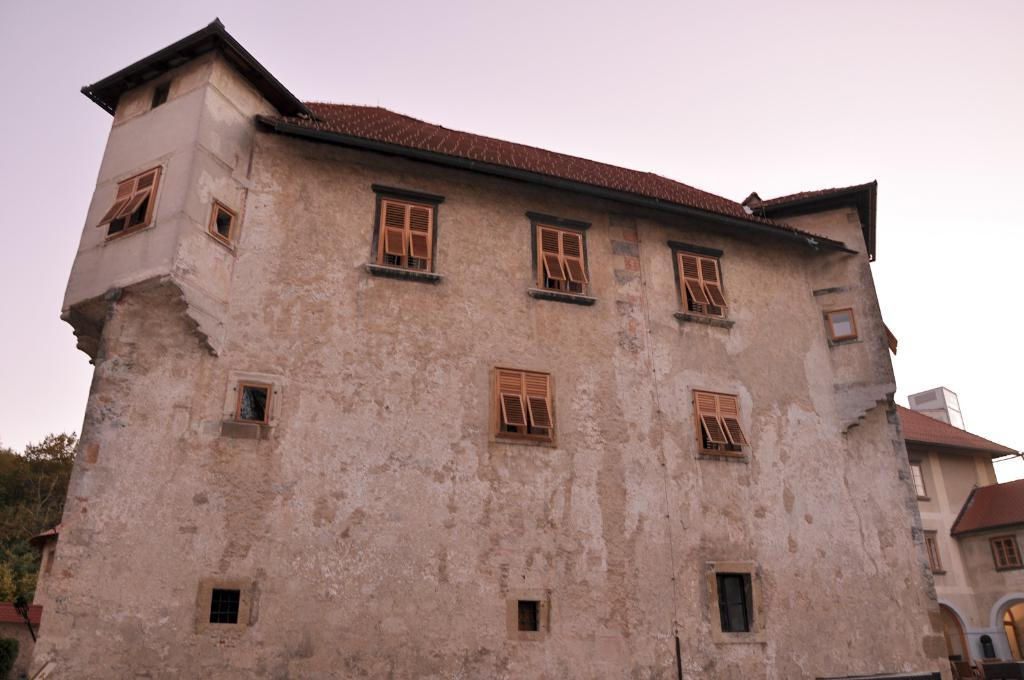What is the main structure in the middle of the image? There is a building in the middle of the image. What type of vegetation is on the left side of the image? There are trees on the left side of the image. What is visible at the top of the image? The sky is visible at the top of the image. What feature can be seen on the building? There are windows in the middle of the building. Where is the scarecrow located in the image? There is no scarecrow present in the image. What type of frame is used to support the building in the image? The image does not show any frame supporting the building; it only shows the building itself. 